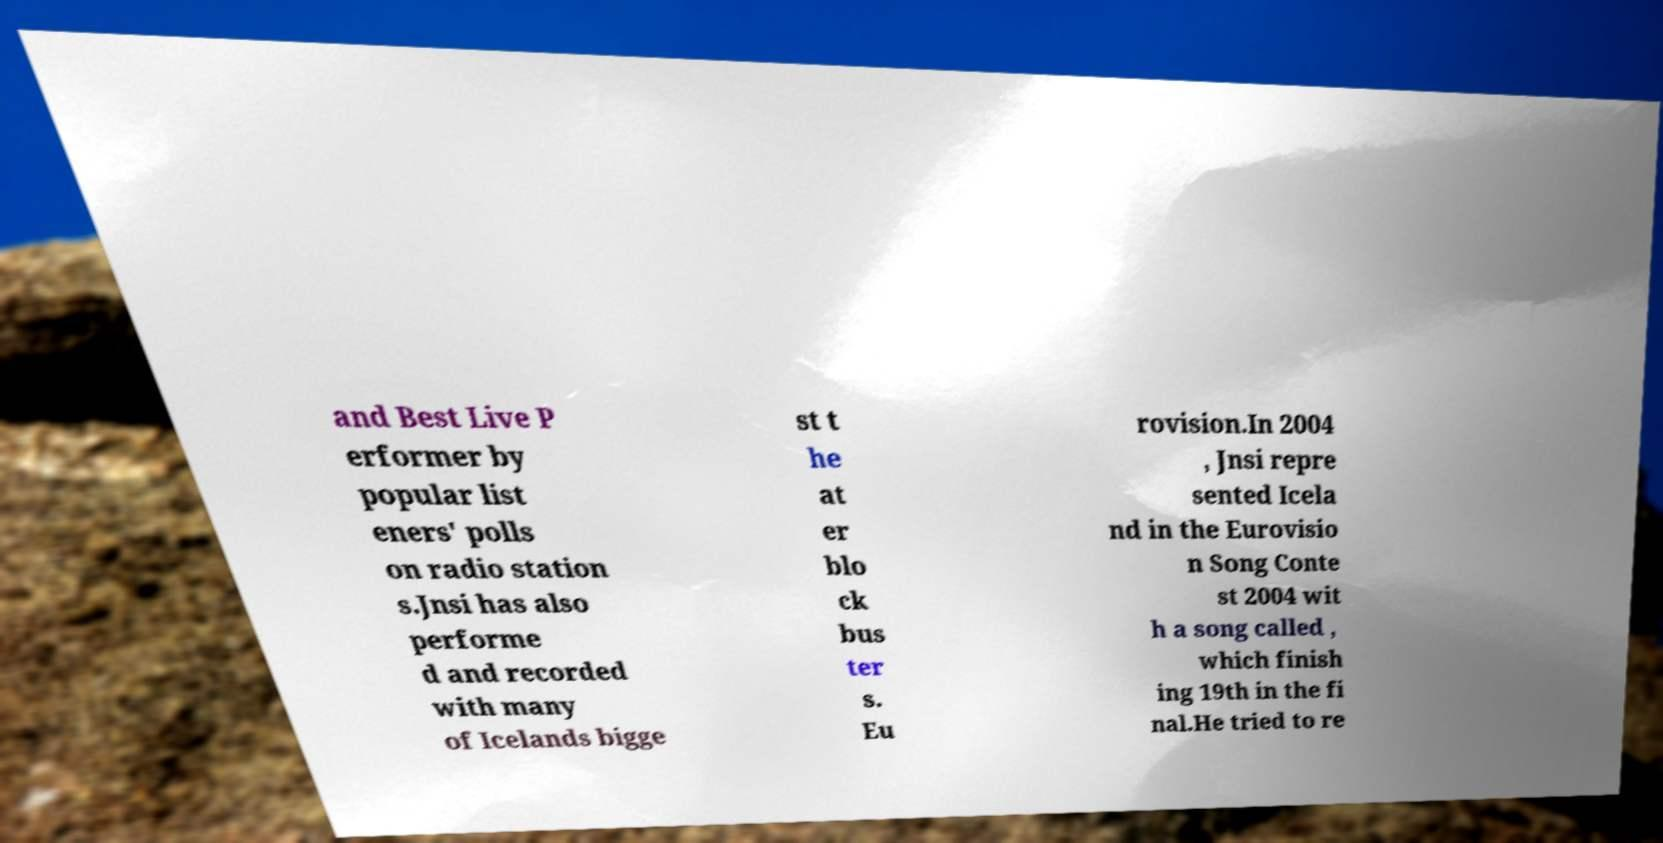Could you extract and type out the text from this image? and Best Live P erformer by popular list eners' polls on radio station s.Jnsi has also performe d and recorded with many of Icelands bigge st t he at er blo ck bus ter s. Eu rovision.In 2004 , Jnsi repre sented Icela nd in the Eurovisio n Song Conte st 2004 wit h a song called , which finish ing 19th in the fi nal.He tried to re 